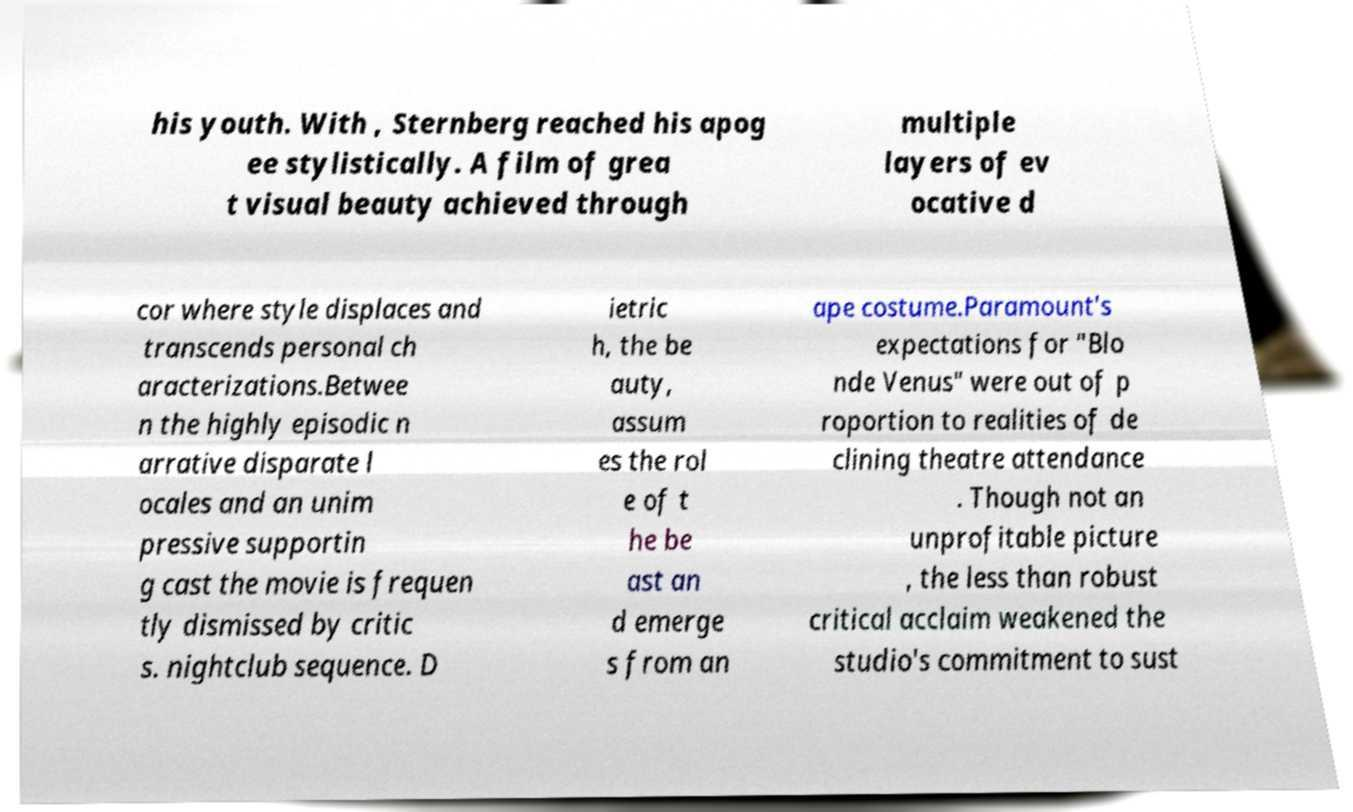Please identify and transcribe the text found in this image. his youth. With , Sternberg reached his apog ee stylistically. A film of grea t visual beauty achieved through multiple layers of ev ocative d cor where style displaces and transcends personal ch aracterizations.Betwee n the highly episodic n arrative disparate l ocales and an unim pressive supportin g cast the movie is frequen tly dismissed by critic s. nightclub sequence. D ietric h, the be auty, assum es the rol e of t he be ast an d emerge s from an ape costume.Paramount's expectations for "Blo nde Venus" were out of p roportion to realities of de clining theatre attendance . Though not an unprofitable picture , the less than robust critical acclaim weakened the studio's commitment to sust 